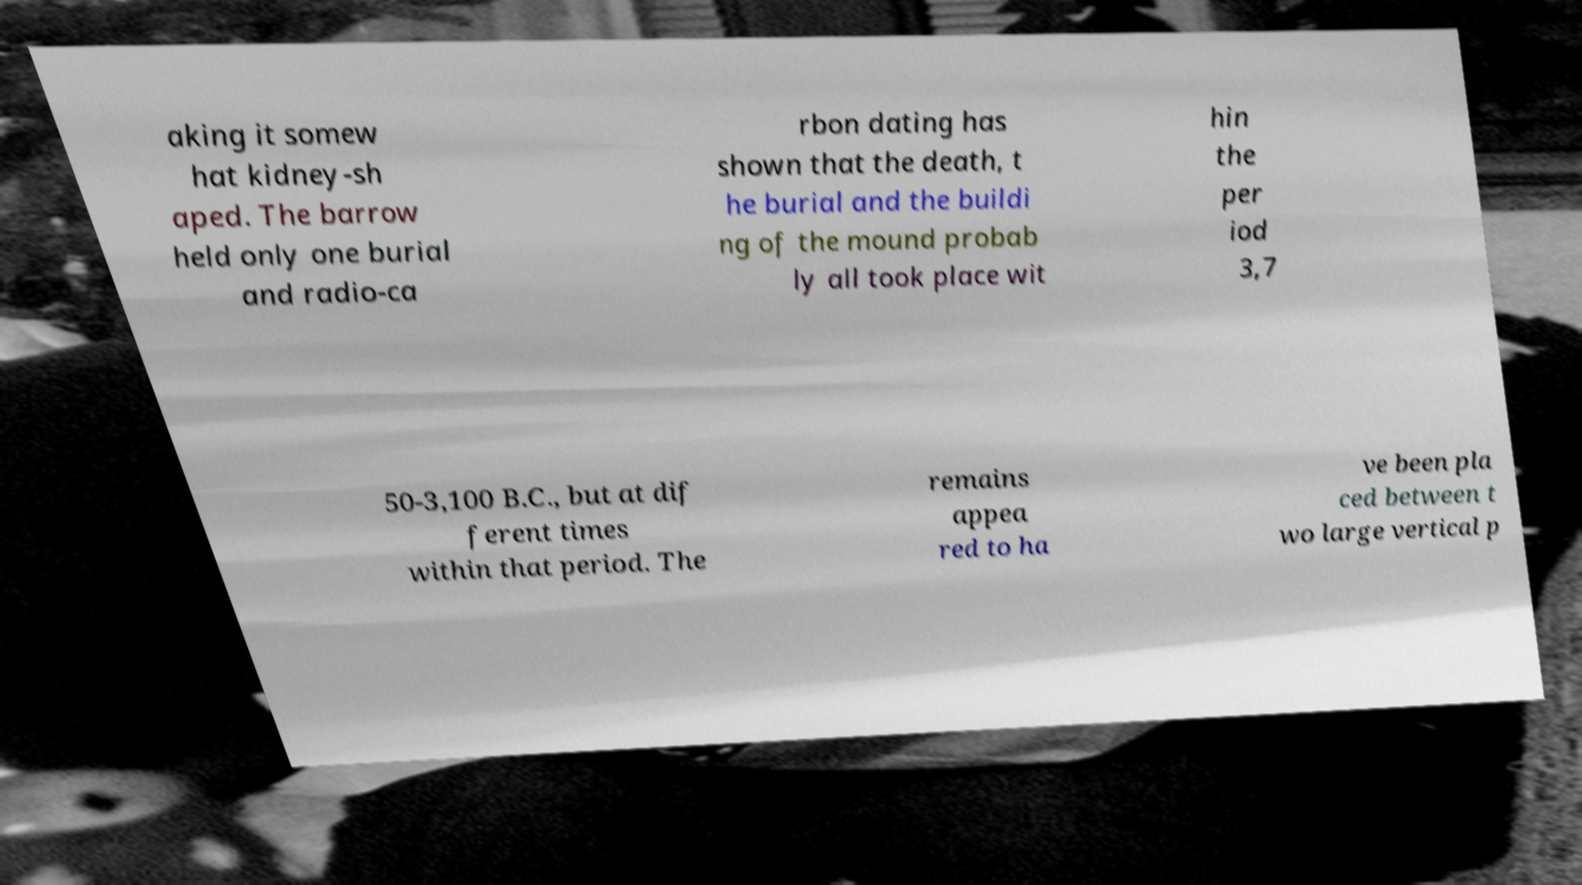Please identify and transcribe the text found in this image. aking it somew hat kidney-sh aped. The barrow held only one burial and radio-ca rbon dating has shown that the death, t he burial and the buildi ng of the mound probab ly all took place wit hin the per iod 3,7 50-3,100 B.C., but at dif ferent times within that period. The remains appea red to ha ve been pla ced between t wo large vertical p 